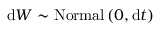Convert formula to latex. <formula><loc_0><loc_0><loc_500><loc_500>d W \sim N o r m a l \left ( 0 , d t \right )</formula> 